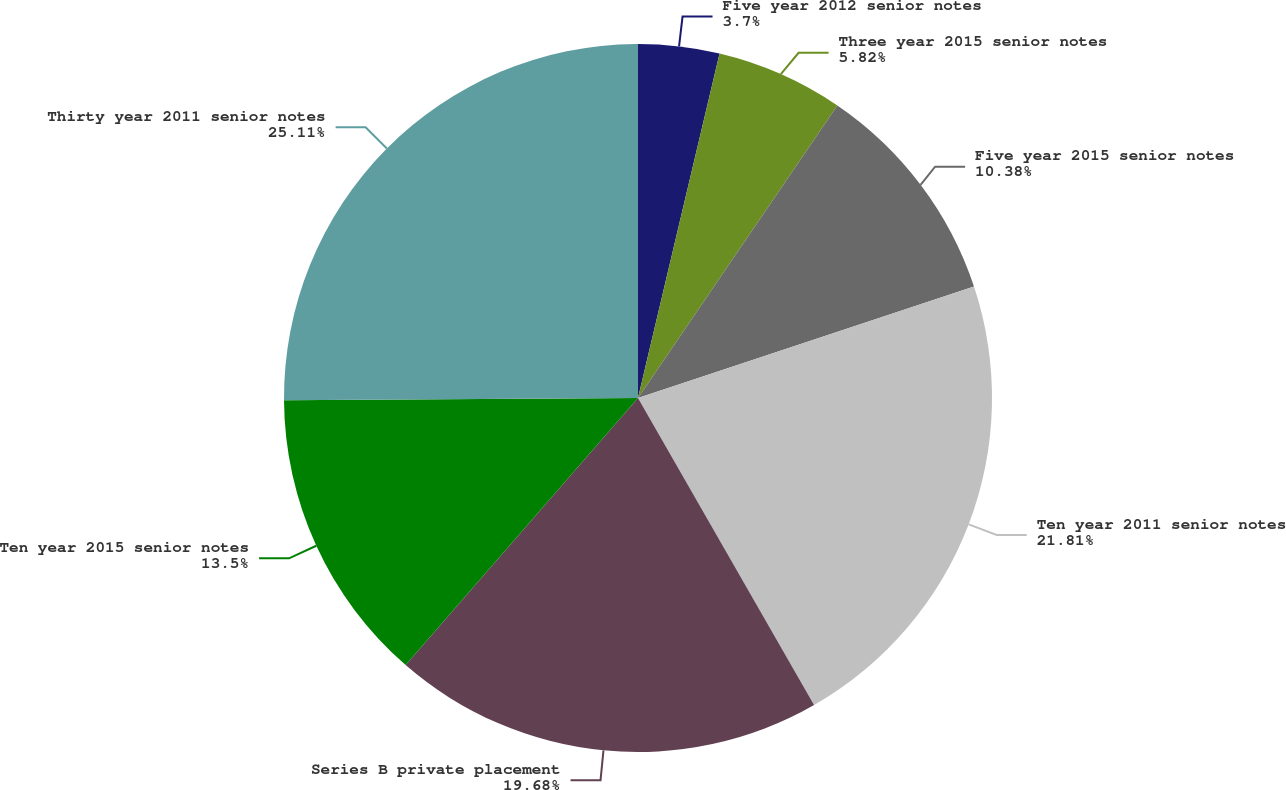Convert chart to OTSL. <chart><loc_0><loc_0><loc_500><loc_500><pie_chart><fcel>Five year 2012 senior notes<fcel>Three year 2015 senior notes<fcel>Five year 2015 senior notes<fcel>Ten year 2011 senior notes<fcel>Series B private placement<fcel>Ten year 2015 senior notes<fcel>Thirty year 2011 senior notes<nl><fcel>3.7%<fcel>5.82%<fcel>10.38%<fcel>21.81%<fcel>19.68%<fcel>13.5%<fcel>25.1%<nl></chart> 